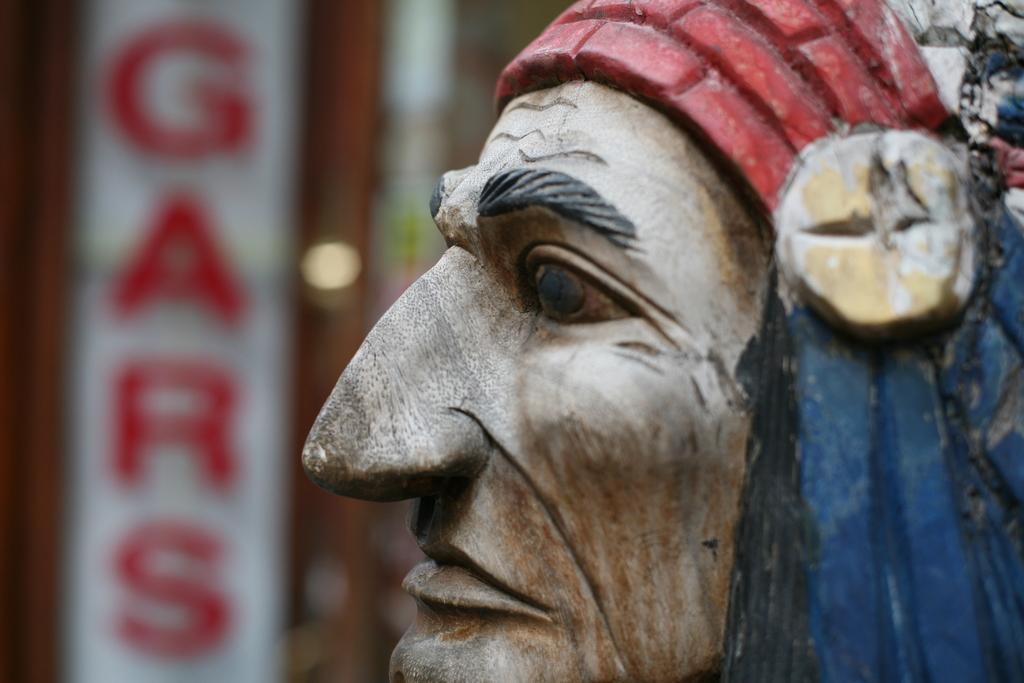What is the main subject in the front of the image? There is a sculpture in the front of the image. What can be seen in the background of the image? There is a board with text in the background of the image. Where is the heart located in the image? There is no heart present in the image; it only features a sculpture and a board with text. 